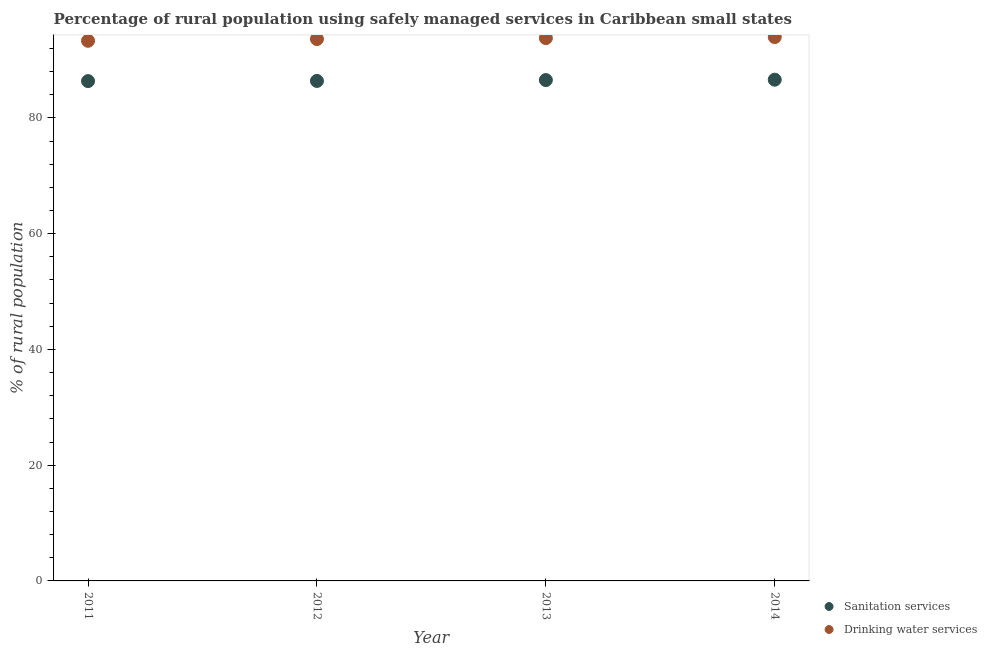How many different coloured dotlines are there?
Offer a terse response. 2. Is the number of dotlines equal to the number of legend labels?
Your response must be concise. Yes. What is the percentage of rural population who used sanitation services in 2011?
Offer a very short reply. 86.36. Across all years, what is the maximum percentage of rural population who used drinking water services?
Provide a short and direct response. 93.96. Across all years, what is the minimum percentage of rural population who used drinking water services?
Your answer should be very brief. 93.32. In which year was the percentage of rural population who used sanitation services maximum?
Offer a terse response. 2014. What is the total percentage of rural population who used drinking water services in the graph?
Your response must be concise. 374.69. What is the difference between the percentage of rural population who used drinking water services in 2013 and that in 2014?
Keep it short and to the point. -0.18. What is the difference between the percentage of rural population who used sanitation services in 2014 and the percentage of rural population who used drinking water services in 2012?
Your response must be concise. -7.02. What is the average percentage of rural population who used sanitation services per year?
Provide a short and direct response. 86.47. In the year 2013, what is the difference between the percentage of rural population who used sanitation services and percentage of rural population who used drinking water services?
Provide a succinct answer. -7.25. In how many years, is the percentage of rural population who used drinking water services greater than 24 %?
Your answer should be very brief. 4. What is the ratio of the percentage of rural population who used drinking water services in 2011 to that in 2012?
Provide a succinct answer. 1. What is the difference between the highest and the second highest percentage of rural population who used sanitation services?
Keep it short and to the point. 0.06. What is the difference between the highest and the lowest percentage of rural population who used sanitation services?
Your answer should be very brief. 0.24. Is the sum of the percentage of rural population who used drinking water services in 2012 and 2013 greater than the maximum percentage of rural population who used sanitation services across all years?
Offer a terse response. Yes. Is the percentage of rural population who used sanitation services strictly less than the percentage of rural population who used drinking water services over the years?
Keep it short and to the point. Yes. What is the difference between two consecutive major ticks on the Y-axis?
Make the answer very short. 20. Are the values on the major ticks of Y-axis written in scientific E-notation?
Make the answer very short. No. Does the graph contain any zero values?
Offer a very short reply. No. Where does the legend appear in the graph?
Provide a succinct answer. Bottom right. How many legend labels are there?
Offer a very short reply. 2. What is the title of the graph?
Give a very brief answer. Percentage of rural population using safely managed services in Caribbean small states. What is the label or title of the X-axis?
Ensure brevity in your answer.  Year. What is the label or title of the Y-axis?
Give a very brief answer. % of rural population. What is the % of rural population of Sanitation services in 2011?
Offer a terse response. 86.36. What is the % of rural population in Drinking water services in 2011?
Ensure brevity in your answer.  93.32. What is the % of rural population of Sanitation services in 2012?
Provide a succinct answer. 86.38. What is the % of rural population of Drinking water services in 2012?
Offer a very short reply. 93.62. What is the % of rural population of Sanitation services in 2013?
Your answer should be compact. 86.54. What is the % of rural population in Drinking water services in 2013?
Ensure brevity in your answer.  93.79. What is the % of rural population in Sanitation services in 2014?
Keep it short and to the point. 86.6. What is the % of rural population in Drinking water services in 2014?
Keep it short and to the point. 93.96. Across all years, what is the maximum % of rural population in Sanitation services?
Your answer should be compact. 86.6. Across all years, what is the maximum % of rural population of Drinking water services?
Ensure brevity in your answer.  93.96. Across all years, what is the minimum % of rural population of Sanitation services?
Keep it short and to the point. 86.36. Across all years, what is the minimum % of rural population of Drinking water services?
Make the answer very short. 93.32. What is the total % of rural population in Sanitation services in the graph?
Give a very brief answer. 345.87. What is the total % of rural population in Drinking water services in the graph?
Provide a succinct answer. 374.69. What is the difference between the % of rural population in Sanitation services in 2011 and that in 2012?
Your response must be concise. -0.03. What is the difference between the % of rural population in Drinking water services in 2011 and that in 2012?
Your response must be concise. -0.3. What is the difference between the % of rural population in Sanitation services in 2011 and that in 2013?
Offer a terse response. -0.18. What is the difference between the % of rural population of Drinking water services in 2011 and that in 2013?
Offer a very short reply. -0.47. What is the difference between the % of rural population of Sanitation services in 2011 and that in 2014?
Provide a short and direct response. -0.24. What is the difference between the % of rural population in Drinking water services in 2011 and that in 2014?
Give a very brief answer. -0.64. What is the difference between the % of rural population in Sanitation services in 2012 and that in 2013?
Offer a terse response. -0.15. What is the difference between the % of rural population in Drinking water services in 2012 and that in 2013?
Provide a short and direct response. -0.16. What is the difference between the % of rural population in Sanitation services in 2012 and that in 2014?
Make the answer very short. -0.21. What is the difference between the % of rural population of Drinking water services in 2012 and that in 2014?
Offer a terse response. -0.34. What is the difference between the % of rural population in Sanitation services in 2013 and that in 2014?
Make the answer very short. -0.06. What is the difference between the % of rural population in Drinking water services in 2013 and that in 2014?
Offer a very short reply. -0.18. What is the difference between the % of rural population of Sanitation services in 2011 and the % of rural population of Drinking water services in 2012?
Your answer should be very brief. -7.27. What is the difference between the % of rural population in Sanitation services in 2011 and the % of rural population in Drinking water services in 2013?
Give a very brief answer. -7.43. What is the difference between the % of rural population of Sanitation services in 2011 and the % of rural population of Drinking water services in 2014?
Provide a short and direct response. -7.61. What is the difference between the % of rural population of Sanitation services in 2012 and the % of rural population of Drinking water services in 2013?
Offer a very short reply. -7.4. What is the difference between the % of rural population of Sanitation services in 2012 and the % of rural population of Drinking water services in 2014?
Offer a very short reply. -7.58. What is the difference between the % of rural population in Sanitation services in 2013 and the % of rural population in Drinking water services in 2014?
Your answer should be compact. -7.43. What is the average % of rural population of Sanitation services per year?
Make the answer very short. 86.47. What is the average % of rural population in Drinking water services per year?
Offer a terse response. 93.67. In the year 2011, what is the difference between the % of rural population in Sanitation services and % of rural population in Drinking water services?
Keep it short and to the point. -6.96. In the year 2012, what is the difference between the % of rural population of Sanitation services and % of rural population of Drinking water services?
Your answer should be very brief. -7.24. In the year 2013, what is the difference between the % of rural population of Sanitation services and % of rural population of Drinking water services?
Your answer should be compact. -7.25. In the year 2014, what is the difference between the % of rural population of Sanitation services and % of rural population of Drinking water services?
Provide a succinct answer. -7.36. What is the ratio of the % of rural population of Sanitation services in 2011 to that in 2013?
Make the answer very short. 1. What is the ratio of the % of rural population of Drinking water services in 2011 to that in 2013?
Offer a very short reply. 0.99. What is the ratio of the % of rural population of Sanitation services in 2011 to that in 2014?
Your answer should be compact. 1. What is the ratio of the % of rural population in Sanitation services in 2012 to that in 2014?
Keep it short and to the point. 1. What is the ratio of the % of rural population of Drinking water services in 2012 to that in 2014?
Ensure brevity in your answer.  1. What is the ratio of the % of rural population of Sanitation services in 2013 to that in 2014?
Offer a very short reply. 1. What is the difference between the highest and the second highest % of rural population of Sanitation services?
Make the answer very short. 0.06. What is the difference between the highest and the second highest % of rural population of Drinking water services?
Your answer should be very brief. 0.18. What is the difference between the highest and the lowest % of rural population in Sanitation services?
Give a very brief answer. 0.24. What is the difference between the highest and the lowest % of rural population of Drinking water services?
Your answer should be compact. 0.64. 